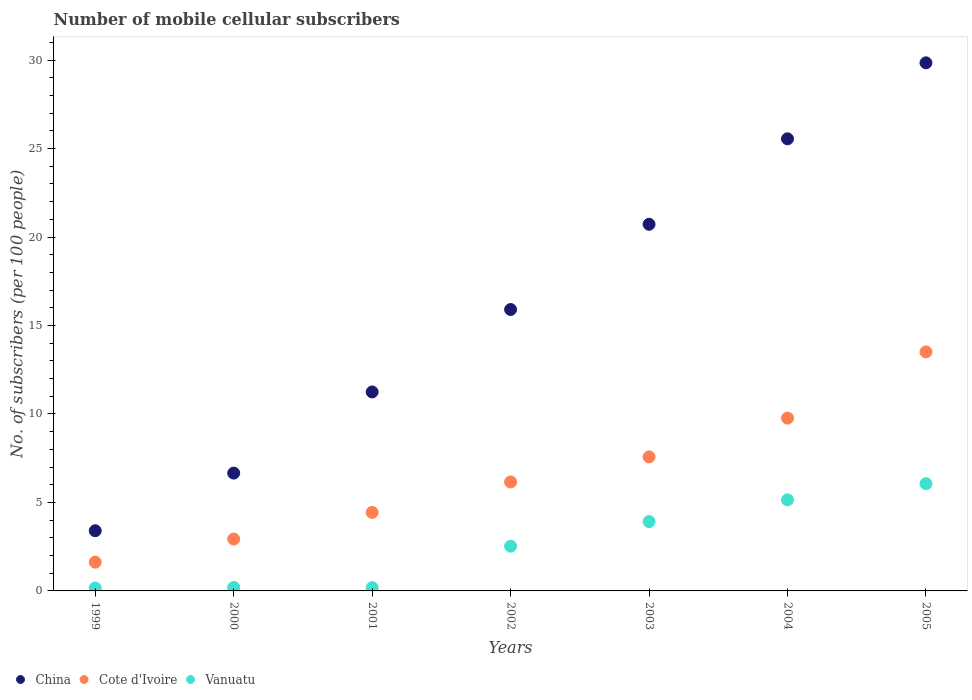How many different coloured dotlines are there?
Provide a succinct answer. 3. Is the number of dotlines equal to the number of legend labels?
Your response must be concise. Yes. What is the number of mobile cellular subscribers in China in 1999?
Offer a very short reply. 3.4. Across all years, what is the maximum number of mobile cellular subscribers in Cote d'Ivoire?
Offer a terse response. 13.51. Across all years, what is the minimum number of mobile cellular subscribers in Vanuatu?
Give a very brief answer. 0.17. What is the total number of mobile cellular subscribers in Vanuatu in the graph?
Offer a terse response. 18.2. What is the difference between the number of mobile cellular subscribers in Vanuatu in 1999 and that in 2003?
Provide a short and direct response. -3.76. What is the difference between the number of mobile cellular subscribers in Vanuatu in 1999 and the number of mobile cellular subscribers in Cote d'Ivoire in 2001?
Provide a short and direct response. -4.27. What is the average number of mobile cellular subscribers in Vanuatu per year?
Offer a very short reply. 2.6. In the year 2000, what is the difference between the number of mobile cellular subscribers in Vanuatu and number of mobile cellular subscribers in China?
Your answer should be very brief. -6.46. In how many years, is the number of mobile cellular subscribers in China greater than 4?
Your answer should be compact. 6. What is the ratio of the number of mobile cellular subscribers in China in 2000 to that in 2001?
Your answer should be very brief. 0.59. Is the number of mobile cellular subscribers in Cote d'Ivoire in 2000 less than that in 2004?
Provide a succinct answer. Yes. Is the difference between the number of mobile cellular subscribers in Vanuatu in 2001 and 2002 greater than the difference between the number of mobile cellular subscribers in China in 2001 and 2002?
Your answer should be compact. Yes. What is the difference between the highest and the second highest number of mobile cellular subscribers in China?
Your response must be concise. 4.29. What is the difference between the highest and the lowest number of mobile cellular subscribers in Cote d'Ivoire?
Make the answer very short. 11.88. In how many years, is the number of mobile cellular subscribers in Vanuatu greater than the average number of mobile cellular subscribers in Vanuatu taken over all years?
Keep it short and to the point. 3. Is it the case that in every year, the sum of the number of mobile cellular subscribers in China and number of mobile cellular subscribers in Cote d'Ivoire  is greater than the number of mobile cellular subscribers in Vanuatu?
Make the answer very short. Yes. How many dotlines are there?
Ensure brevity in your answer.  3. How many years are there in the graph?
Ensure brevity in your answer.  7. Are the values on the major ticks of Y-axis written in scientific E-notation?
Your response must be concise. No. Does the graph contain any zero values?
Your response must be concise. No. How many legend labels are there?
Give a very brief answer. 3. How are the legend labels stacked?
Your answer should be compact. Horizontal. What is the title of the graph?
Provide a short and direct response. Number of mobile cellular subscribers. What is the label or title of the Y-axis?
Your answer should be compact. No. of subscribers (per 100 people). What is the No. of subscribers (per 100 people) in China in 1999?
Offer a very short reply. 3.4. What is the No. of subscribers (per 100 people) of Cote d'Ivoire in 1999?
Your answer should be very brief. 1.63. What is the No. of subscribers (per 100 people) of Vanuatu in 1999?
Make the answer very short. 0.17. What is the No. of subscribers (per 100 people) of China in 2000?
Your answer should be compact. 6.66. What is the No. of subscribers (per 100 people) of Cote d'Ivoire in 2000?
Ensure brevity in your answer.  2.93. What is the No. of subscribers (per 100 people) in Vanuatu in 2000?
Keep it short and to the point. 0.2. What is the No. of subscribers (per 100 people) in China in 2001?
Keep it short and to the point. 11.24. What is the No. of subscribers (per 100 people) in Cote d'Ivoire in 2001?
Keep it short and to the point. 4.44. What is the No. of subscribers (per 100 people) in Vanuatu in 2001?
Your answer should be compact. 0.18. What is the No. of subscribers (per 100 people) in China in 2002?
Offer a very short reply. 15.9. What is the No. of subscribers (per 100 people) of Cote d'Ivoire in 2002?
Provide a succinct answer. 6.16. What is the No. of subscribers (per 100 people) of Vanuatu in 2002?
Offer a terse response. 2.53. What is the No. of subscribers (per 100 people) in China in 2003?
Your answer should be compact. 20.72. What is the No. of subscribers (per 100 people) in Cote d'Ivoire in 2003?
Your response must be concise. 7.57. What is the No. of subscribers (per 100 people) of Vanuatu in 2003?
Your response must be concise. 3.92. What is the No. of subscribers (per 100 people) in China in 2004?
Offer a very short reply. 25.55. What is the No. of subscribers (per 100 people) in Cote d'Ivoire in 2004?
Keep it short and to the point. 9.77. What is the No. of subscribers (per 100 people) of Vanuatu in 2004?
Make the answer very short. 5.15. What is the No. of subscribers (per 100 people) of China in 2005?
Offer a terse response. 29.84. What is the No. of subscribers (per 100 people) of Cote d'Ivoire in 2005?
Your answer should be compact. 13.51. What is the No. of subscribers (per 100 people) of Vanuatu in 2005?
Offer a terse response. 6.06. Across all years, what is the maximum No. of subscribers (per 100 people) of China?
Keep it short and to the point. 29.84. Across all years, what is the maximum No. of subscribers (per 100 people) of Cote d'Ivoire?
Offer a very short reply. 13.51. Across all years, what is the maximum No. of subscribers (per 100 people) of Vanuatu?
Offer a terse response. 6.06. Across all years, what is the minimum No. of subscribers (per 100 people) in China?
Provide a succinct answer. 3.4. Across all years, what is the minimum No. of subscribers (per 100 people) of Cote d'Ivoire?
Keep it short and to the point. 1.63. Across all years, what is the minimum No. of subscribers (per 100 people) of Vanuatu?
Make the answer very short. 0.17. What is the total No. of subscribers (per 100 people) of China in the graph?
Your answer should be compact. 113.33. What is the total No. of subscribers (per 100 people) of Cote d'Ivoire in the graph?
Your response must be concise. 46. What is the total No. of subscribers (per 100 people) of Vanuatu in the graph?
Give a very brief answer. 18.2. What is the difference between the No. of subscribers (per 100 people) of China in 1999 and that in 2000?
Offer a very short reply. -3.26. What is the difference between the No. of subscribers (per 100 people) of Cote d'Ivoire in 1999 and that in 2000?
Your answer should be compact. -1.3. What is the difference between the No. of subscribers (per 100 people) of Vanuatu in 1999 and that in 2000?
Provide a succinct answer. -0.03. What is the difference between the No. of subscribers (per 100 people) of China in 1999 and that in 2001?
Provide a succinct answer. -7.84. What is the difference between the No. of subscribers (per 100 people) in Cote d'Ivoire in 1999 and that in 2001?
Keep it short and to the point. -2.81. What is the difference between the No. of subscribers (per 100 people) in Vanuatu in 1999 and that in 2001?
Your response must be concise. -0.02. What is the difference between the No. of subscribers (per 100 people) in China in 1999 and that in 2002?
Your response must be concise. -12.5. What is the difference between the No. of subscribers (per 100 people) of Cote d'Ivoire in 1999 and that in 2002?
Give a very brief answer. -4.53. What is the difference between the No. of subscribers (per 100 people) of Vanuatu in 1999 and that in 2002?
Ensure brevity in your answer.  -2.36. What is the difference between the No. of subscribers (per 100 people) in China in 1999 and that in 2003?
Give a very brief answer. -17.32. What is the difference between the No. of subscribers (per 100 people) of Cote d'Ivoire in 1999 and that in 2003?
Keep it short and to the point. -5.95. What is the difference between the No. of subscribers (per 100 people) in Vanuatu in 1999 and that in 2003?
Your answer should be compact. -3.76. What is the difference between the No. of subscribers (per 100 people) of China in 1999 and that in 2004?
Offer a terse response. -22.15. What is the difference between the No. of subscribers (per 100 people) in Cote d'Ivoire in 1999 and that in 2004?
Your response must be concise. -8.14. What is the difference between the No. of subscribers (per 100 people) of Vanuatu in 1999 and that in 2004?
Your answer should be very brief. -4.98. What is the difference between the No. of subscribers (per 100 people) of China in 1999 and that in 2005?
Provide a succinct answer. -26.44. What is the difference between the No. of subscribers (per 100 people) in Cote d'Ivoire in 1999 and that in 2005?
Your answer should be compact. -11.88. What is the difference between the No. of subscribers (per 100 people) in Vanuatu in 1999 and that in 2005?
Offer a terse response. -5.9. What is the difference between the No. of subscribers (per 100 people) in China in 2000 and that in 2001?
Your answer should be very brief. -4.59. What is the difference between the No. of subscribers (per 100 people) of Cote d'Ivoire in 2000 and that in 2001?
Offer a terse response. -1.5. What is the difference between the No. of subscribers (per 100 people) in Vanuatu in 2000 and that in 2001?
Your answer should be very brief. 0.01. What is the difference between the No. of subscribers (per 100 people) in China in 2000 and that in 2002?
Give a very brief answer. -9.25. What is the difference between the No. of subscribers (per 100 people) of Cote d'Ivoire in 2000 and that in 2002?
Your answer should be compact. -3.23. What is the difference between the No. of subscribers (per 100 people) in Vanuatu in 2000 and that in 2002?
Make the answer very short. -2.33. What is the difference between the No. of subscribers (per 100 people) in China in 2000 and that in 2003?
Offer a very short reply. -14.06. What is the difference between the No. of subscribers (per 100 people) in Cote d'Ivoire in 2000 and that in 2003?
Make the answer very short. -4.64. What is the difference between the No. of subscribers (per 100 people) in Vanuatu in 2000 and that in 2003?
Provide a short and direct response. -3.72. What is the difference between the No. of subscribers (per 100 people) of China in 2000 and that in 2004?
Make the answer very short. -18.89. What is the difference between the No. of subscribers (per 100 people) of Cote d'Ivoire in 2000 and that in 2004?
Your answer should be compact. -6.83. What is the difference between the No. of subscribers (per 100 people) in Vanuatu in 2000 and that in 2004?
Provide a short and direct response. -4.95. What is the difference between the No. of subscribers (per 100 people) of China in 2000 and that in 2005?
Make the answer very short. -23.19. What is the difference between the No. of subscribers (per 100 people) of Cote d'Ivoire in 2000 and that in 2005?
Provide a succinct answer. -10.58. What is the difference between the No. of subscribers (per 100 people) in Vanuatu in 2000 and that in 2005?
Make the answer very short. -5.86. What is the difference between the No. of subscribers (per 100 people) in China in 2001 and that in 2002?
Offer a terse response. -4.66. What is the difference between the No. of subscribers (per 100 people) in Cote d'Ivoire in 2001 and that in 2002?
Give a very brief answer. -1.72. What is the difference between the No. of subscribers (per 100 people) in Vanuatu in 2001 and that in 2002?
Make the answer very short. -2.34. What is the difference between the No. of subscribers (per 100 people) of China in 2001 and that in 2003?
Your answer should be compact. -9.48. What is the difference between the No. of subscribers (per 100 people) of Cote d'Ivoire in 2001 and that in 2003?
Keep it short and to the point. -3.14. What is the difference between the No. of subscribers (per 100 people) in Vanuatu in 2001 and that in 2003?
Your answer should be compact. -3.74. What is the difference between the No. of subscribers (per 100 people) in China in 2001 and that in 2004?
Your answer should be compact. -14.31. What is the difference between the No. of subscribers (per 100 people) of Cote d'Ivoire in 2001 and that in 2004?
Your response must be concise. -5.33. What is the difference between the No. of subscribers (per 100 people) in Vanuatu in 2001 and that in 2004?
Ensure brevity in your answer.  -4.96. What is the difference between the No. of subscribers (per 100 people) of China in 2001 and that in 2005?
Your response must be concise. -18.6. What is the difference between the No. of subscribers (per 100 people) in Cote d'Ivoire in 2001 and that in 2005?
Your answer should be very brief. -9.07. What is the difference between the No. of subscribers (per 100 people) in Vanuatu in 2001 and that in 2005?
Your answer should be compact. -5.88. What is the difference between the No. of subscribers (per 100 people) of China in 2002 and that in 2003?
Your response must be concise. -4.82. What is the difference between the No. of subscribers (per 100 people) of Cote d'Ivoire in 2002 and that in 2003?
Keep it short and to the point. -1.41. What is the difference between the No. of subscribers (per 100 people) of Vanuatu in 2002 and that in 2003?
Keep it short and to the point. -1.39. What is the difference between the No. of subscribers (per 100 people) of China in 2002 and that in 2004?
Ensure brevity in your answer.  -9.65. What is the difference between the No. of subscribers (per 100 people) of Cote d'Ivoire in 2002 and that in 2004?
Make the answer very short. -3.61. What is the difference between the No. of subscribers (per 100 people) of Vanuatu in 2002 and that in 2004?
Give a very brief answer. -2.62. What is the difference between the No. of subscribers (per 100 people) of China in 2002 and that in 2005?
Provide a succinct answer. -13.94. What is the difference between the No. of subscribers (per 100 people) in Cote d'Ivoire in 2002 and that in 2005?
Your answer should be very brief. -7.35. What is the difference between the No. of subscribers (per 100 people) in Vanuatu in 2002 and that in 2005?
Offer a very short reply. -3.54. What is the difference between the No. of subscribers (per 100 people) of China in 2003 and that in 2004?
Your response must be concise. -4.83. What is the difference between the No. of subscribers (per 100 people) of Cote d'Ivoire in 2003 and that in 2004?
Your response must be concise. -2.19. What is the difference between the No. of subscribers (per 100 people) in Vanuatu in 2003 and that in 2004?
Your response must be concise. -1.23. What is the difference between the No. of subscribers (per 100 people) of China in 2003 and that in 2005?
Ensure brevity in your answer.  -9.12. What is the difference between the No. of subscribers (per 100 people) in Cote d'Ivoire in 2003 and that in 2005?
Your response must be concise. -5.93. What is the difference between the No. of subscribers (per 100 people) of Vanuatu in 2003 and that in 2005?
Offer a terse response. -2.14. What is the difference between the No. of subscribers (per 100 people) of China in 2004 and that in 2005?
Your answer should be compact. -4.29. What is the difference between the No. of subscribers (per 100 people) of Cote d'Ivoire in 2004 and that in 2005?
Make the answer very short. -3.74. What is the difference between the No. of subscribers (per 100 people) of Vanuatu in 2004 and that in 2005?
Make the answer very short. -0.92. What is the difference between the No. of subscribers (per 100 people) in China in 1999 and the No. of subscribers (per 100 people) in Cote d'Ivoire in 2000?
Keep it short and to the point. 0.47. What is the difference between the No. of subscribers (per 100 people) of China in 1999 and the No. of subscribers (per 100 people) of Vanuatu in 2000?
Your response must be concise. 3.2. What is the difference between the No. of subscribers (per 100 people) of Cote d'Ivoire in 1999 and the No. of subscribers (per 100 people) of Vanuatu in 2000?
Ensure brevity in your answer.  1.43. What is the difference between the No. of subscribers (per 100 people) in China in 1999 and the No. of subscribers (per 100 people) in Cote d'Ivoire in 2001?
Ensure brevity in your answer.  -1.04. What is the difference between the No. of subscribers (per 100 people) in China in 1999 and the No. of subscribers (per 100 people) in Vanuatu in 2001?
Ensure brevity in your answer.  3.22. What is the difference between the No. of subscribers (per 100 people) in Cote d'Ivoire in 1999 and the No. of subscribers (per 100 people) in Vanuatu in 2001?
Your answer should be very brief. 1.44. What is the difference between the No. of subscribers (per 100 people) of China in 1999 and the No. of subscribers (per 100 people) of Cote d'Ivoire in 2002?
Your answer should be compact. -2.76. What is the difference between the No. of subscribers (per 100 people) of China in 1999 and the No. of subscribers (per 100 people) of Vanuatu in 2002?
Your answer should be very brief. 0.87. What is the difference between the No. of subscribers (per 100 people) in Cote d'Ivoire in 1999 and the No. of subscribers (per 100 people) in Vanuatu in 2002?
Your response must be concise. -0.9. What is the difference between the No. of subscribers (per 100 people) in China in 1999 and the No. of subscribers (per 100 people) in Cote d'Ivoire in 2003?
Keep it short and to the point. -4.17. What is the difference between the No. of subscribers (per 100 people) of China in 1999 and the No. of subscribers (per 100 people) of Vanuatu in 2003?
Your answer should be compact. -0.52. What is the difference between the No. of subscribers (per 100 people) of Cote d'Ivoire in 1999 and the No. of subscribers (per 100 people) of Vanuatu in 2003?
Your answer should be compact. -2.29. What is the difference between the No. of subscribers (per 100 people) of China in 1999 and the No. of subscribers (per 100 people) of Cote d'Ivoire in 2004?
Provide a succinct answer. -6.36. What is the difference between the No. of subscribers (per 100 people) of China in 1999 and the No. of subscribers (per 100 people) of Vanuatu in 2004?
Provide a short and direct response. -1.74. What is the difference between the No. of subscribers (per 100 people) in Cote d'Ivoire in 1999 and the No. of subscribers (per 100 people) in Vanuatu in 2004?
Offer a very short reply. -3.52. What is the difference between the No. of subscribers (per 100 people) of China in 1999 and the No. of subscribers (per 100 people) of Cote d'Ivoire in 2005?
Offer a very short reply. -10.11. What is the difference between the No. of subscribers (per 100 people) in China in 1999 and the No. of subscribers (per 100 people) in Vanuatu in 2005?
Offer a very short reply. -2.66. What is the difference between the No. of subscribers (per 100 people) of Cote d'Ivoire in 1999 and the No. of subscribers (per 100 people) of Vanuatu in 2005?
Offer a very short reply. -4.43. What is the difference between the No. of subscribers (per 100 people) in China in 2000 and the No. of subscribers (per 100 people) in Cote d'Ivoire in 2001?
Your response must be concise. 2.22. What is the difference between the No. of subscribers (per 100 people) of China in 2000 and the No. of subscribers (per 100 people) of Vanuatu in 2001?
Make the answer very short. 6.47. What is the difference between the No. of subscribers (per 100 people) of Cote d'Ivoire in 2000 and the No. of subscribers (per 100 people) of Vanuatu in 2001?
Give a very brief answer. 2.75. What is the difference between the No. of subscribers (per 100 people) of China in 2000 and the No. of subscribers (per 100 people) of Cote d'Ivoire in 2002?
Keep it short and to the point. 0.5. What is the difference between the No. of subscribers (per 100 people) in China in 2000 and the No. of subscribers (per 100 people) in Vanuatu in 2002?
Your answer should be very brief. 4.13. What is the difference between the No. of subscribers (per 100 people) in Cote d'Ivoire in 2000 and the No. of subscribers (per 100 people) in Vanuatu in 2002?
Your answer should be compact. 0.41. What is the difference between the No. of subscribers (per 100 people) in China in 2000 and the No. of subscribers (per 100 people) in Cote d'Ivoire in 2003?
Your answer should be compact. -0.92. What is the difference between the No. of subscribers (per 100 people) in China in 2000 and the No. of subscribers (per 100 people) in Vanuatu in 2003?
Provide a succinct answer. 2.74. What is the difference between the No. of subscribers (per 100 people) in Cote d'Ivoire in 2000 and the No. of subscribers (per 100 people) in Vanuatu in 2003?
Keep it short and to the point. -0.99. What is the difference between the No. of subscribers (per 100 people) in China in 2000 and the No. of subscribers (per 100 people) in Cote d'Ivoire in 2004?
Offer a very short reply. -3.11. What is the difference between the No. of subscribers (per 100 people) in China in 2000 and the No. of subscribers (per 100 people) in Vanuatu in 2004?
Your answer should be very brief. 1.51. What is the difference between the No. of subscribers (per 100 people) of Cote d'Ivoire in 2000 and the No. of subscribers (per 100 people) of Vanuatu in 2004?
Your response must be concise. -2.21. What is the difference between the No. of subscribers (per 100 people) of China in 2000 and the No. of subscribers (per 100 people) of Cote d'Ivoire in 2005?
Provide a short and direct response. -6.85. What is the difference between the No. of subscribers (per 100 people) in China in 2000 and the No. of subscribers (per 100 people) in Vanuatu in 2005?
Your response must be concise. 0.6. What is the difference between the No. of subscribers (per 100 people) in Cote d'Ivoire in 2000 and the No. of subscribers (per 100 people) in Vanuatu in 2005?
Offer a very short reply. -3.13. What is the difference between the No. of subscribers (per 100 people) in China in 2001 and the No. of subscribers (per 100 people) in Cote d'Ivoire in 2002?
Ensure brevity in your answer.  5.09. What is the difference between the No. of subscribers (per 100 people) of China in 2001 and the No. of subscribers (per 100 people) of Vanuatu in 2002?
Offer a terse response. 8.72. What is the difference between the No. of subscribers (per 100 people) of Cote d'Ivoire in 2001 and the No. of subscribers (per 100 people) of Vanuatu in 2002?
Offer a very short reply. 1.91. What is the difference between the No. of subscribers (per 100 people) of China in 2001 and the No. of subscribers (per 100 people) of Cote d'Ivoire in 2003?
Your response must be concise. 3.67. What is the difference between the No. of subscribers (per 100 people) of China in 2001 and the No. of subscribers (per 100 people) of Vanuatu in 2003?
Your response must be concise. 7.32. What is the difference between the No. of subscribers (per 100 people) of Cote d'Ivoire in 2001 and the No. of subscribers (per 100 people) of Vanuatu in 2003?
Your answer should be compact. 0.52. What is the difference between the No. of subscribers (per 100 people) of China in 2001 and the No. of subscribers (per 100 people) of Cote d'Ivoire in 2004?
Ensure brevity in your answer.  1.48. What is the difference between the No. of subscribers (per 100 people) of China in 2001 and the No. of subscribers (per 100 people) of Vanuatu in 2004?
Give a very brief answer. 6.1. What is the difference between the No. of subscribers (per 100 people) of Cote d'Ivoire in 2001 and the No. of subscribers (per 100 people) of Vanuatu in 2004?
Your response must be concise. -0.71. What is the difference between the No. of subscribers (per 100 people) in China in 2001 and the No. of subscribers (per 100 people) in Cote d'Ivoire in 2005?
Your response must be concise. -2.26. What is the difference between the No. of subscribers (per 100 people) in China in 2001 and the No. of subscribers (per 100 people) in Vanuatu in 2005?
Your response must be concise. 5.18. What is the difference between the No. of subscribers (per 100 people) of Cote d'Ivoire in 2001 and the No. of subscribers (per 100 people) of Vanuatu in 2005?
Offer a terse response. -1.62. What is the difference between the No. of subscribers (per 100 people) in China in 2002 and the No. of subscribers (per 100 people) in Cote d'Ivoire in 2003?
Offer a very short reply. 8.33. What is the difference between the No. of subscribers (per 100 people) of China in 2002 and the No. of subscribers (per 100 people) of Vanuatu in 2003?
Make the answer very short. 11.98. What is the difference between the No. of subscribers (per 100 people) in Cote d'Ivoire in 2002 and the No. of subscribers (per 100 people) in Vanuatu in 2003?
Give a very brief answer. 2.24. What is the difference between the No. of subscribers (per 100 people) of China in 2002 and the No. of subscribers (per 100 people) of Cote d'Ivoire in 2004?
Keep it short and to the point. 6.14. What is the difference between the No. of subscribers (per 100 people) of China in 2002 and the No. of subscribers (per 100 people) of Vanuatu in 2004?
Ensure brevity in your answer.  10.76. What is the difference between the No. of subscribers (per 100 people) in Cote d'Ivoire in 2002 and the No. of subscribers (per 100 people) in Vanuatu in 2004?
Offer a very short reply. 1.01. What is the difference between the No. of subscribers (per 100 people) in China in 2002 and the No. of subscribers (per 100 people) in Cote d'Ivoire in 2005?
Ensure brevity in your answer.  2.4. What is the difference between the No. of subscribers (per 100 people) of China in 2002 and the No. of subscribers (per 100 people) of Vanuatu in 2005?
Ensure brevity in your answer.  9.84. What is the difference between the No. of subscribers (per 100 people) of Cote d'Ivoire in 2002 and the No. of subscribers (per 100 people) of Vanuatu in 2005?
Your answer should be compact. 0.1. What is the difference between the No. of subscribers (per 100 people) of China in 2003 and the No. of subscribers (per 100 people) of Cote d'Ivoire in 2004?
Offer a very short reply. 10.95. What is the difference between the No. of subscribers (per 100 people) in China in 2003 and the No. of subscribers (per 100 people) in Vanuatu in 2004?
Your response must be concise. 15.58. What is the difference between the No. of subscribers (per 100 people) in Cote d'Ivoire in 2003 and the No. of subscribers (per 100 people) in Vanuatu in 2004?
Your answer should be compact. 2.43. What is the difference between the No. of subscribers (per 100 people) of China in 2003 and the No. of subscribers (per 100 people) of Cote d'Ivoire in 2005?
Provide a short and direct response. 7.21. What is the difference between the No. of subscribers (per 100 people) in China in 2003 and the No. of subscribers (per 100 people) in Vanuatu in 2005?
Make the answer very short. 14.66. What is the difference between the No. of subscribers (per 100 people) in Cote d'Ivoire in 2003 and the No. of subscribers (per 100 people) in Vanuatu in 2005?
Your answer should be very brief. 1.51. What is the difference between the No. of subscribers (per 100 people) in China in 2004 and the No. of subscribers (per 100 people) in Cote d'Ivoire in 2005?
Provide a succinct answer. 12.04. What is the difference between the No. of subscribers (per 100 people) of China in 2004 and the No. of subscribers (per 100 people) of Vanuatu in 2005?
Make the answer very short. 19.49. What is the difference between the No. of subscribers (per 100 people) of Cote d'Ivoire in 2004 and the No. of subscribers (per 100 people) of Vanuatu in 2005?
Offer a very short reply. 3.7. What is the average No. of subscribers (per 100 people) of China per year?
Make the answer very short. 16.19. What is the average No. of subscribers (per 100 people) of Cote d'Ivoire per year?
Your answer should be very brief. 6.57. What is the average No. of subscribers (per 100 people) in Vanuatu per year?
Your response must be concise. 2.6. In the year 1999, what is the difference between the No. of subscribers (per 100 people) of China and No. of subscribers (per 100 people) of Cote d'Ivoire?
Your answer should be compact. 1.77. In the year 1999, what is the difference between the No. of subscribers (per 100 people) of China and No. of subscribers (per 100 people) of Vanuatu?
Give a very brief answer. 3.24. In the year 1999, what is the difference between the No. of subscribers (per 100 people) of Cote d'Ivoire and No. of subscribers (per 100 people) of Vanuatu?
Your answer should be very brief. 1.46. In the year 2000, what is the difference between the No. of subscribers (per 100 people) of China and No. of subscribers (per 100 people) of Cote d'Ivoire?
Your answer should be compact. 3.73. In the year 2000, what is the difference between the No. of subscribers (per 100 people) in China and No. of subscribers (per 100 people) in Vanuatu?
Provide a succinct answer. 6.46. In the year 2000, what is the difference between the No. of subscribers (per 100 people) in Cote d'Ivoire and No. of subscribers (per 100 people) in Vanuatu?
Ensure brevity in your answer.  2.73. In the year 2001, what is the difference between the No. of subscribers (per 100 people) in China and No. of subscribers (per 100 people) in Cote d'Ivoire?
Provide a succinct answer. 6.81. In the year 2001, what is the difference between the No. of subscribers (per 100 people) of China and No. of subscribers (per 100 people) of Vanuatu?
Give a very brief answer. 11.06. In the year 2001, what is the difference between the No. of subscribers (per 100 people) of Cote d'Ivoire and No. of subscribers (per 100 people) of Vanuatu?
Keep it short and to the point. 4.25. In the year 2002, what is the difference between the No. of subscribers (per 100 people) in China and No. of subscribers (per 100 people) in Cote d'Ivoire?
Ensure brevity in your answer.  9.74. In the year 2002, what is the difference between the No. of subscribers (per 100 people) in China and No. of subscribers (per 100 people) in Vanuatu?
Offer a terse response. 13.38. In the year 2002, what is the difference between the No. of subscribers (per 100 people) in Cote d'Ivoire and No. of subscribers (per 100 people) in Vanuatu?
Give a very brief answer. 3.63. In the year 2003, what is the difference between the No. of subscribers (per 100 people) of China and No. of subscribers (per 100 people) of Cote d'Ivoire?
Offer a very short reply. 13.15. In the year 2003, what is the difference between the No. of subscribers (per 100 people) in China and No. of subscribers (per 100 people) in Vanuatu?
Offer a terse response. 16.8. In the year 2003, what is the difference between the No. of subscribers (per 100 people) of Cote d'Ivoire and No. of subscribers (per 100 people) of Vanuatu?
Offer a terse response. 3.65. In the year 2004, what is the difference between the No. of subscribers (per 100 people) of China and No. of subscribers (per 100 people) of Cote d'Ivoire?
Your response must be concise. 15.78. In the year 2004, what is the difference between the No. of subscribers (per 100 people) of China and No. of subscribers (per 100 people) of Vanuatu?
Keep it short and to the point. 20.41. In the year 2004, what is the difference between the No. of subscribers (per 100 people) of Cote d'Ivoire and No. of subscribers (per 100 people) of Vanuatu?
Your answer should be compact. 4.62. In the year 2005, what is the difference between the No. of subscribers (per 100 people) in China and No. of subscribers (per 100 people) in Cote d'Ivoire?
Keep it short and to the point. 16.34. In the year 2005, what is the difference between the No. of subscribers (per 100 people) of China and No. of subscribers (per 100 people) of Vanuatu?
Offer a terse response. 23.78. In the year 2005, what is the difference between the No. of subscribers (per 100 people) in Cote d'Ivoire and No. of subscribers (per 100 people) in Vanuatu?
Offer a very short reply. 7.45. What is the ratio of the No. of subscribers (per 100 people) in China in 1999 to that in 2000?
Provide a succinct answer. 0.51. What is the ratio of the No. of subscribers (per 100 people) in Cote d'Ivoire in 1999 to that in 2000?
Your response must be concise. 0.56. What is the ratio of the No. of subscribers (per 100 people) of Vanuatu in 1999 to that in 2000?
Keep it short and to the point. 0.84. What is the ratio of the No. of subscribers (per 100 people) of China in 1999 to that in 2001?
Your response must be concise. 0.3. What is the ratio of the No. of subscribers (per 100 people) of Cote d'Ivoire in 1999 to that in 2001?
Make the answer very short. 0.37. What is the ratio of the No. of subscribers (per 100 people) of Vanuatu in 1999 to that in 2001?
Your response must be concise. 0.89. What is the ratio of the No. of subscribers (per 100 people) in China in 1999 to that in 2002?
Your answer should be compact. 0.21. What is the ratio of the No. of subscribers (per 100 people) in Cote d'Ivoire in 1999 to that in 2002?
Provide a short and direct response. 0.26. What is the ratio of the No. of subscribers (per 100 people) of Vanuatu in 1999 to that in 2002?
Provide a succinct answer. 0.07. What is the ratio of the No. of subscribers (per 100 people) in China in 1999 to that in 2003?
Give a very brief answer. 0.16. What is the ratio of the No. of subscribers (per 100 people) of Cote d'Ivoire in 1999 to that in 2003?
Your answer should be compact. 0.21. What is the ratio of the No. of subscribers (per 100 people) of Vanuatu in 1999 to that in 2003?
Make the answer very short. 0.04. What is the ratio of the No. of subscribers (per 100 people) in China in 1999 to that in 2004?
Your response must be concise. 0.13. What is the ratio of the No. of subscribers (per 100 people) of Cote d'Ivoire in 1999 to that in 2004?
Offer a terse response. 0.17. What is the ratio of the No. of subscribers (per 100 people) of Vanuatu in 1999 to that in 2004?
Provide a succinct answer. 0.03. What is the ratio of the No. of subscribers (per 100 people) in China in 1999 to that in 2005?
Ensure brevity in your answer.  0.11. What is the ratio of the No. of subscribers (per 100 people) of Cote d'Ivoire in 1999 to that in 2005?
Make the answer very short. 0.12. What is the ratio of the No. of subscribers (per 100 people) in Vanuatu in 1999 to that in 2005?
Offer a terse response. 0.03. What is the ratio of the No. of subscribers (per 100 people) of China in 2000 to that in 2001?
Keep it short and to the point. 0.59. What is the ratio of the No. of subscribers (per 100 people) in Cote d'Ivoire in 2000 to that in 2001?
Provide a short and direct response. 0.66. What is the ratio of the No. of subscribers (per 100 people) of Vanuatu in 2000 to that in 2001?
Offer a very short reply. 1.07. What is the ratio of the No. of subscribers (per 100 people) in China in 2000 to that in 2002?
Provide a succinct answer. 0.42. What is the ratio of the No. of subscribers (per 100 people) in Cote d'Ivoire in 2000 to that in 2002?
Your response must be concise. 0.48. What is the ratio of the No. of subscribers (per 100 people) in Vanuatu in 2000 to that in 2002?
Make the answer very short. 0.08. What is the ratio of the No. of subscribers (per 100 people) in China in 2000 to that in 2003?
Your answer should be very brief. 0.32. What is the ratio of the No. of subscribers (per 100 people) of Cote d'Ivoire in 2000 to that in 2003?
Ensure brevity in your answer.  0.39. What is the ratio of the No. of subscribers (per 100 people) in Vanuatu in 2000 to that in 2003?
Your answer should be compact. 0.05. What is the ratio of the No. of subscribers (per 100 people) of China in 2000 to that in 2004?
Give a very brief answer. 0.26. What is the ratio of the No. of subscribers (per 100 people) in Cote d'Ivoire in 2000 to that in 2004?
Make the answer very short. 0.3. What is the ratio of the No. of subscribers (per 100 people) in Vanuatu in 2000 to that in 2004?
Give a very brief answer. 0.04. What is the ratio of the No. of subscribers (per 100 people) of China in 2000 to that in 2005?
Make the answer very short. 0.22. What is the ratio of the No. of subscribers (per 100 people) of Cote d'Ivoire in 2000 to that in 2005?
Your answer should be very brief. 0.22. What is the ratio of the No. of subscribers (per 100 people) of Vanuatu in 2000 to that in 2005?
Your answer should be very brief. 0.03. What is the ratio of the No. of subscribers (per 100 people) in China in 2001 to that in 2002?
Provide a short and direct response. 0.71. What is the ratio of the No. of subscribers (per 100 people) of Cote d'Ivoire in 2001 to that in 2002?
Your answer should be compact. 0.72. What is the ratio of the No. of subscribers (per 100 people) in Vanuatu in 2001 to that in 2002?
Your answer should be compact. 0.07. What is the ratio of the No. of subscribers (per 100 people) in China in 2001 to that in 2003?
Your answer should be very brief. 0.54. What is the ratio of the No. of subscribers (per 100 people) of Cote d'Ivoire in 2001 to that in 2003?
Your response must be concise. 0.59. What is the ratio of the No. of subscribers (per 100 people) in Vanuatu in 2001 to that in 2003?
Provide a short and direct response. 0.05. What is the ratio of the No. of subscribers (per 100 people) of China in 2001 to that in 2004?
Give a very brief answer. 0.44. What is the ratio of the No. of subscribers (per 100 people) of Cote d'Ivoire in 2001 to that in 2004?
Ensure brevity in your answer.  0.45. What is the ratio of the No. of subscribers (per 100 people) of Vanuatu in 2001 to that in 2004?
Your answer should be compact. 0.04. What is the ratio of the No. of subscribers (per 100 people) of China in 2001 to that in 2005?
Offer a terse response. 0.38. What is the ratio of the No. of subscribers (per 100 people) in Cote d'Ivoire in 2001 to that in 2005?
Provide a short and direct response. 0.33. What is the ratio of the No. of subscribers (per 100 people) in Vanuatu in 2001 to that in 2005?
Give a very brief answer. 0.03. What is the ratio of the No. of subscribers (per 100 people) in China in 2002 to that in 2003?
Your response must be concise. 0.77. What is the ratio of the No. of subscribers (per 100 people) of Cote d'Ivoire in 2002 to that in 2003?
Ensure brevity in your answer.  0.81. What is the ratio of the No. of subscribers (per 100 people) of Vanuatu in 2002 to that in 2003?
Offer a very short reply. 0.64. What is the ratio of the No. of subscribers (per 100 people) of China in 2002 to that in 2004?
Provide a succinct answer. 0.62. What is the ratio of the No. of subscribers (per 100 people) in Cote d'Ivoire in 2002 to that in 2004?
Ensure brevity in your answer.  0.63. What is the ratio of the No. of subscribers (per 100 people) in Vanuatu in 2002 to that in 2004?
Offer a terse response. 0.49. What is the ratio of the No. of subscribers (per 100 people) in China in 2002 to that in 2005?
Your response must be concise. 0.53. What is the ratio of the No. of subscribers (per 100 people) in Cote d'Ivoire in 2002 to that in 2005?
Ensure brevity in your answer.  0.46. What is the ratio of the No. of subscribers (per 100 people) in Vanuatu in 2002 to that in 2005?
Your answer should be very brief. 0.42. What is the ratio of the No. of subscribers (per 100 people) of China in 2003 to that in 2004?
Your answer should be compact. 0.81. What is the ratio of the No. of subscribers (per 100 people) in Cote d'Ivoire in 2003 to that in 2004?
Provide a short and direct response. 0.78. What is the ratio of the No. of subscribers (per 100 people) of Vanuatu in 2003 to that in 2004?
Your response must be concise. 0.76. What is the ratio of the No. of subscribers (per 100 people) in China in 2003 to that in 2005?
Make the answer very short. 0.69. What is the ratio of the No. of subscribers (per 100 people) of Cote d'Ivoire in 2003 to that in 2005?
Make the answer very short. 0.56. What is the ratio of the No. of subscribers (per 100 people) in Vanuatu in 2003 to that in 2005?
Provide a short and direct response. 0.65. What is the ratio of the No. of subscribers (per 100 people) of China in 2004 to that in 2005?
Make the answer very short. 0.86. What is the ratio of the No. of subscribers (per 100 people) of Cote d'Ivoire in 2004 to that in 2005?
Offer a very short reply. 0.72. What is the ratio of the No. of subscribers (per 100 people) of Vanuatu in 2004 to that in 2005?
Provide a succinct answer. 0.85. What is the difference between the highest and the second highest No. of subscribers (per 100 people) in China?
Ensure brevity in your answer.  4.29. What is the difference between the highest and the second highest No. of subscribers (per 100 people) in Cote d'Ivoire?
Offer a very short reply. 3.74. What is the difference between the highest and the second highest No. of subscribers (per 100 people) in Vanuatu?
Make the answer very short. 0.92. What is the difference between the highest and the lowest No. of subscribers (per 100 people) of China?
Offer a very short reply. 26.44. What is the difference between the highest and the lowest No. of subscribers (per 100 people) in Cote d'Ivoire?
Keep it short and to the point. 11.88. What is the difference between the highest and the lowest No. of subscribers (per 100 people) in Vanuatu?
Provide a succinct answer. 5.9. 